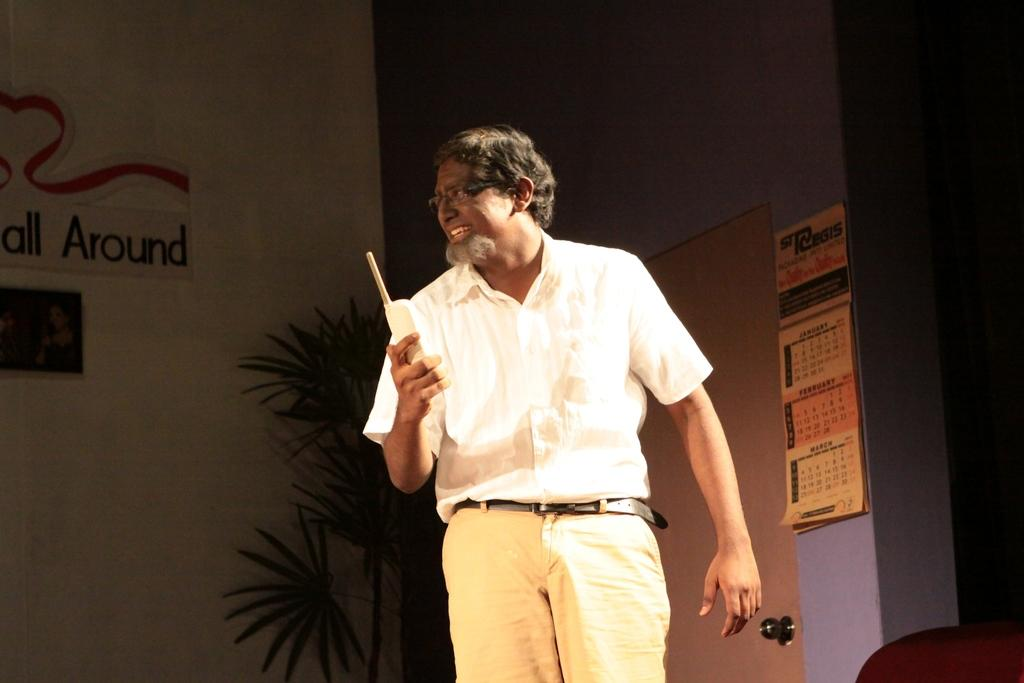What is the main subject of the image? There is a man standing in the center of the image. What is the man holding in his hand? The man is holding a walkie talkie in his hand. What can be seen in the background of the image? There is a plant, a board, and a door visible in the background of the image. What type of current is flowing through the plant in the image? There is no indication of any current flowing through the plant in the image. 